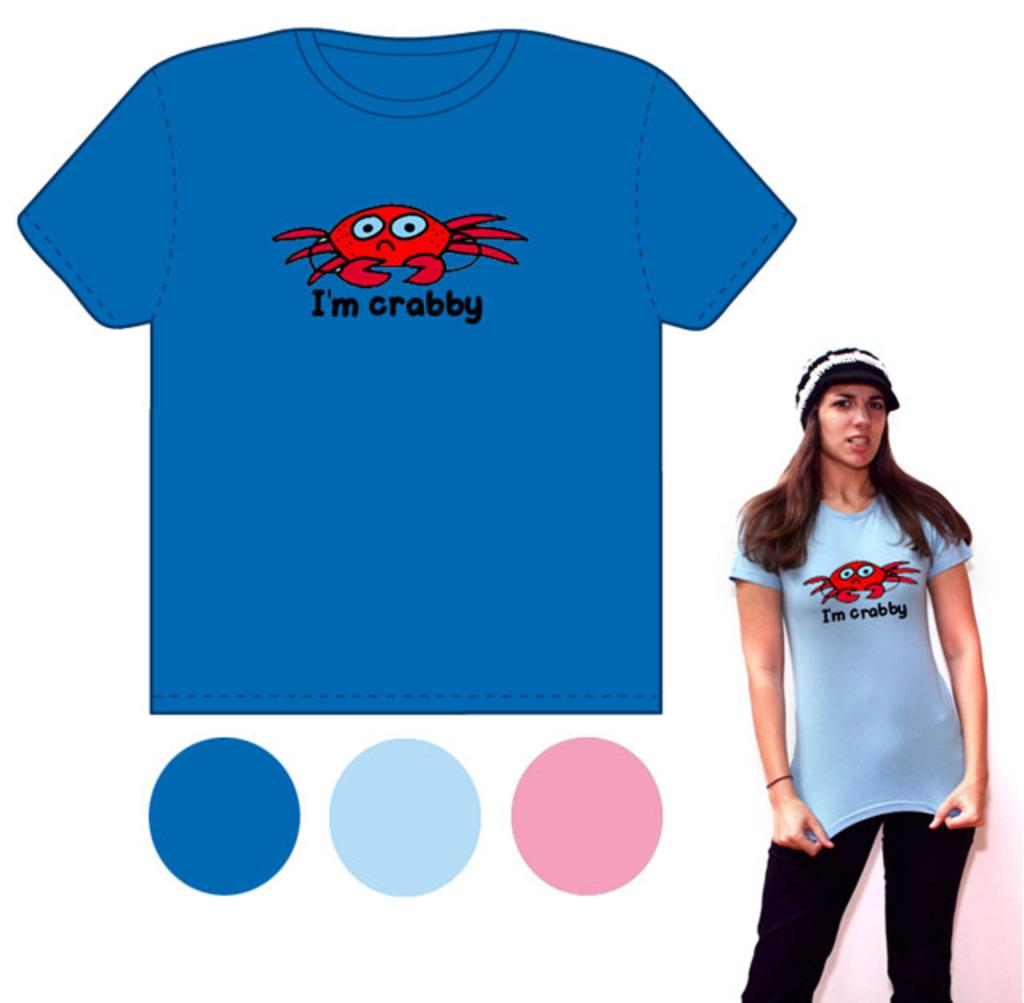<image>
Present a compact description of the photo's key features. A shirt with a crab has the phrase I'm crabby on it. 